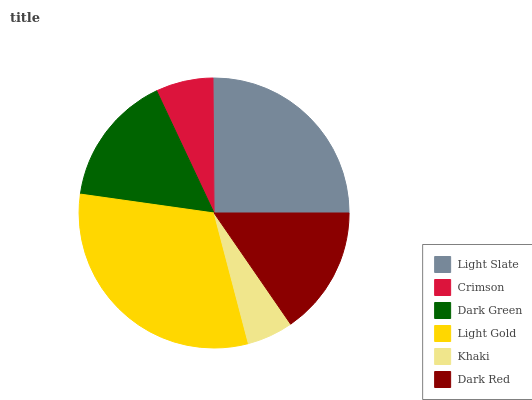Is Khaki the minimum?
Answer yes or no. Yes. Is Light Gold the maximum?
Answer yes or no. Yes. Is Crimson the minimum?
Answer yes or no. No. Is Crimson the maximum?
Answer yes or no. No. Is Light Slate greater than Crimson?
Answer yes or no. Yes. Is Crimson less than Light Slate?
Answer yes or no. Yes. Is Crimson greater than Light Slate?
Answer yes or no. No. Is Light Slate less than Crimson?
Answer yes or no. No. Is Dark Green the high median?
Answer yes or no. Yes. Is Dark Red the low median?
Answer yes or no. Yes. Is Light Slate the high median?
Answer yes or no. No. Is Light Slate the low median?
Answer yes or no. No. 